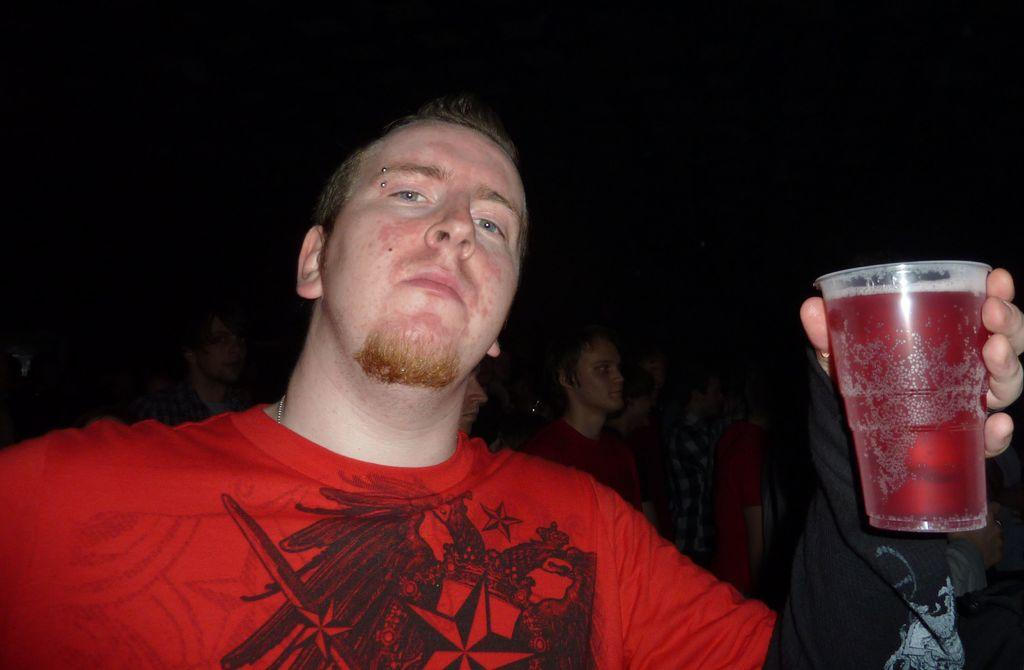What is the main subject of the image? There is a person in the image. What is the person holding in his hand? The person is holding a cup in his hand. Can you describe the background of the image? The background of the image is dark. Are there any other people visible in the image? Yes, there are a few people visible in the background. What type of lace can be seen on the person's clothing in the image? There is no lace visible on the person's clothing in the image. How much salt can be seen on the person's hand in the image? There is no salt visible on the person's hand in the image. 